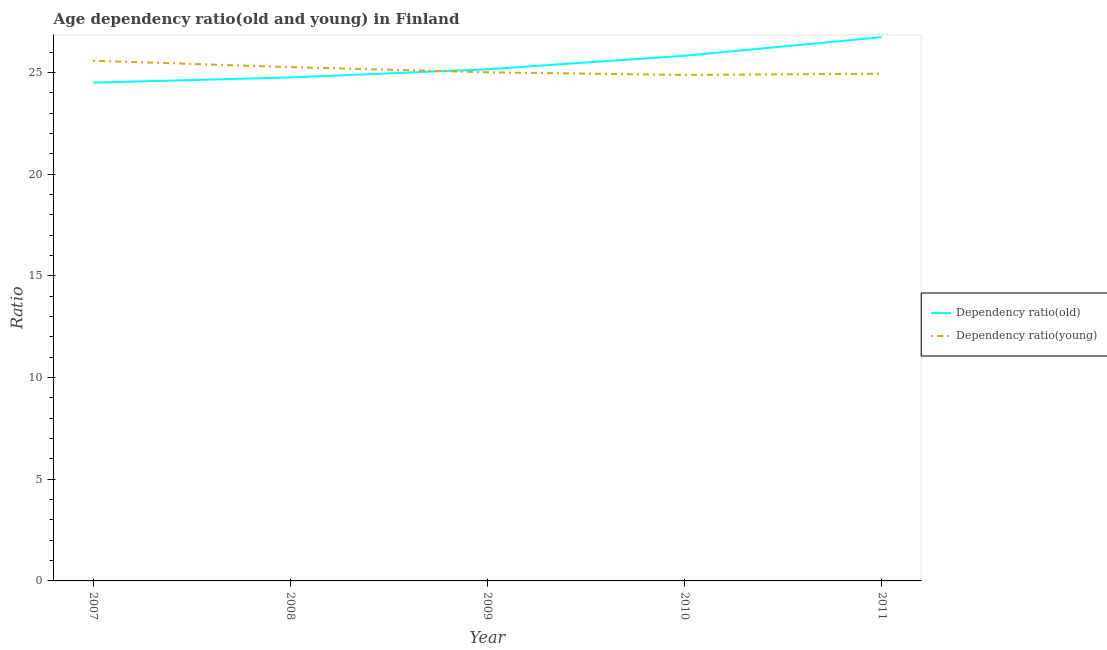What is the age dependency ratio(young) in 2007?
Make the answer very short. 25.57. Across all years, what is the maximum age dependency ratio(old)?
Make the answer very short. 26.73. Across all years, what is the minimum age dependency ratio(young)?
Keep it short and to the point. 24.87. In which year was the age dependency ratio(old) maximum?
Keep it short and to the point. 2011. In which year was the age dependency ratio(young) minimum?
Your answer should be compact. 2010. What is the total age dependency ratio(old) in the graph?
Ensure brevity in your answer.  126.95. What is the difference between the age dependency ratio(young) in 2007 and that in 2008?
Offer a terse response. 0.32. What is the difference between the age dependency ratio(young) in 2010 and the age dependency ratio(old) in 2011?
Make the answer very short. -1.86. What is the average age dependency ratio(young) per year?
Keep it short and to the point. 25.13. In the year 2011, what is the difference between the age dependency ratio(young) and age dependency ratio(old)?
Offer a very short reply. -1.8. In how many years, is the age dependency ratio(old) greater than 8?
Ensure brevity in your answer.  5. What is the ratio of the age dependency ratio(old) in 2007 to that in 2011?
Keep it short and to the point. 0.92. What is the difference between the highest and the second highest age dependency ratio(old)?
Provide a short and direct response. 0.91. What is the difference between the highest and the lowest age dependency ratio(young)?
Your response must be concise. 0.7. Is the sum of the age dependency ratio(young) in 2007 and 2010 greater than the maximum age dependency ratio(old) across all years?
Provide a short and direct response. Yes. Does the age dependency ratio(old) monotonically increase over the years?
Provide a short and direct response. Yes. Is the age dependency ratio(old) strictly greater than the age dependency ratio(young) over the years?
Offer a very short reply. No. How many lines are there?
Offer a very short reply. 2. How many years are there in the graph?
Ensure brevity in your answer.  5. What is the difference between two consecutive major ticks on the Y-axis?
Your answer should be very brief. 5. Are the values on the major ticks of Y-axis written in scientific E-notation?
Your response must be concise. No. Does the graph contain grids?
Your answer should be very brief. No. What is the title of the graph?
Provide a short and direct response. Age dependency ratio(old and young) in Finland. Does "Travel services" appear as one of the legend labels in the graph?
Provide a succinct answer. No. What is the label or title of the Y-axis?
Offer a very short reply. Ratio. What is the Ratio of Dependency ratio(old) in 2007?
Provide a succinct answer. 24.49. What is the Ratio of Dependency ratio(young) in 2007?
Your answer should be very brief. 25.57. What is the Ratio of Dependency ratio(old) in 2008?
Make the answer very short. 24.75. What is the Ratio of Dependency ratio(young) in 2008?
Keep it short and to the point. 25.26. What is the Ratio in Dependency ratio(old) in 2009?
Give a very brief answer. 25.15. What is the Ratio of Dependency ratio(young) in 2009?
Make the answer very short. 25. What is the Ratio of Dependency ratio(old) in 2010?
Your answer should be very brief. 25.82. What is the Ratio of Dependency ratio(young) in 2010?
Your response must be concise. 24.87. What is the Ratio of Dependency ratio(old) in 2011?
Keep it short and to the point. 26.73. What is the Ratio of Dependency ratio(young) in 2011?
Your response must be concise. 24.93. Across all years, what is the maximum Ratio of Dependency ratio(old)?
Offer a terse response. 26.73. Across all years, what is the maximum Ratio in Dependency ratio(young)?
Offer a terse response. 25.57. Across all years, what is the minimum Ratio of Dependency ratio(old)?
Provide a short and direct response. 24.49. Across all years, what is the minimum Ratio in Dependency ratio(young)?
Give a very brief answer. 24.87. What is the total Ratio of Dependency ratio(old) in the graph?
Give a very brief answer. 126.95. What is the total Ratio in Dependency ratio(young) in the graph?
Offer a terse response. 125.64. What is the difference between the Ratio of Dependency ratio(old) in 2007 and that in 2008?
Give a very brief answer. -0.26. What is the difference between the Ratio in Dependency ratio(young) in 2007 and that in 2008?
Your answer should be very brief. 0.32. What is the difference between the Ratio in Dependency ratio(old) in 2007 and that in 2009?
Offer a very short reply. -0.66. What is the difference between the Ratio in Dependency ratio(young) in 2007 and that in 2009?
Provide a short and direct response. 0.57. What is the difference between the Ratio in Dependency ratio(old) in 2007 and that in 2010?
Make the answer very short. -1.32. What is the difference between the Ratio in Dependency ratio(young) in 2007 and that in 2010?
Keep it short and to the point. 0.7. What is the difference between the Ratio of Dependency ratio(old) in 2007 and that in 2011?
Provide a short and direct response. -2.24. What is the difference between the Ratio in Dependency ratio(young) in 2007 and that in 2011?
Your response must be concise. 0.64. What is the difference between the Ratio of Dependency ratio(old) in 2008 and that in 2009?
Make the answer very short. -0.4. What is the difference between the Ratio of Dependency ratio(young) in 2008 and that in 2009?
Keep it short and to the point. 0.26. What is the difference between the Ratio in Dependency ratio(old) in 2008 and that in 2010?
Ensure brevity in your answer.  -1.07. What is the difference between the Ratio in Dependency ratio(young) in 2008 and that in 2010?
Make the answer very short. 0.38. What is the difference between the Ratio in Dependency ratio(old) in 2008 and that in 2011?
Provide a short and direct response. -1.98. What is the difference between the Ratio of Dependency ratio(young) in 2008 and that in 2011?
Your answer should be very brief. 0.32. What is the difference between the Ratio of Dependency ratio(old) in 2009 and that in 2010?
Keep it short and to the point. -0.66. What is the difference between the Ratio of Dependency ratio(young) in 2009 and that in 2010?
Offer a terse response. 0.13. What is the difference between the Ratio of Dependency ratio(old) in 2009 and that in 2011?
Keep it short and to the point. -1.58. What is the difference between the Ratio in Dependency ratio(young) in 2009 and that in 2011?
Provide a succinct answer. 0.07. What is the difference between the Ratio in Dependency ratio(old) in 2010 and that in 2011?
Offer a terse response. -0.91. What is the difference between the Ratio in Dependency ratio(young) in 2010 and that in 2011?
Make the answer very short. -0.06. What is the difference between the Ratio of Dependency ratio(old) in 2007 and the Ratio of Dependency ratio(young) in 2008?
Offer a very short reply. -0.76. What is the difference between the Ratio in Dependency ratio(old) in 2007 and the Ratio in Dependency ratio(young) in 2009?
Make the answer very short. -0.51. What is the difference between the Ratio of Dependency ratio(old) in 2007 and the Ratio of Dependency ratio(young) in 2010?
Offer a terse response. -0.38. What is the difference between the Ratio of Dependency ratio(old) in 2007 and the Ratio of Dependency ratio(young) in 2011?
Offer a very short reply. -0.44. What is the difference between the Ratio of Dependency ratio(old) in 2008 and the Ratio of Dependency ratio(young) in 2009?
Offer a very short reply. -0.25. What is the difference between the Ratio of Dependency ratio(old) in 2008 and the Ratio of Dependency ratio(young) in 2010?
Provide a short and direct response. -0.12. What is the difference between the Ratio of Dependency ratio(old) in 2008 and the Ratio of Dependency ratio(young) in 2011?
Your answer should be very brief. -0.18. What is the difference between the Ratio in Dependency ratio(old) in 2009 and the Ratio in Dependency ratio(young) in 2010?
Make the answer very short. 0.28. What is the difference between the Ratio in Dependency ratio(old) in 2009 and the Ratio in Dependency ratio(young) in 2011?
Your answer should be compact. 0.22. What is the difference between the Ratio in Dependency ratio(old) in 2010 and the Ratio in Dependency ratio(young) in 2011?
Your answer should be compact. 0.88. What is the average Ratio in Dependency ratio(old) per year?
Provide a short and direct response. 25.39. What is the average Ratio of Dependency ratio(young) per year?
Keep it short and to the point. 25.13. In the year 2007, what is the difference between the Ratio in Dependency ratio(old) and Ratio in Dependency ratio(young)?
Your answer should be very brief. -1.08. In the year 2008, what is the difference between the Ratio in Dependency ratio(old) and Ratio in Dependency ratio(young)?
Give a very brief answer. -0.51. In the year 2009, what is the difference between the Ratio in Dependency ratio(old) and Ratio in Dependency ratio(young)?
Ensure brevity in your answer.  0.15. In the year 2010, what is the difference between the Ratio in Dependency ratio(old) and Ratio in Dependency ratio(young)?
Your response must be concise. 0.94. In the year 2011, what is the difference between the Ratio of Dependency ratio(old) and Ratio of Dependency ratio(young)?
Make the answer very short. 1.8. What is the ratio of the Ratio in Dependency ratio(young) in 2007 to that in 2008?
Ensure brevity in your answer.  1.01. What is the ratio of the Ratio of Dependency ratio(old) in 2007 to that in 2009?
Provide a short and direct response. 0.97. What is the ratio of the Ratio of Dependency ratio(young) in 2007 to that in 2009?
Offer a terse response. 1.02. What is the ratio of the Ratio in Dependency ratio(old) in 2007 to that in 2010?
Keep it short and to the point. 0.95. What is the ratio of the Ratio of Dependency ratio(young) in 2007 to that in 2010?
Your answer should be very brief. 1.03. What is the ratio of the Ratio in Dependency ratio(old) in 2007 to that in 2011?
Provide a succinct answer. 0.92. What is the ratio of the Ratio in Dependency ratio(young) in 2007 to that in 2011?
Your response must be concise. 1.03. What is the ratio of the Ratio in Dependency ratio(old) in 2008 to that in 2009?
Offer a very short reply. 0.98. What is the ratio of the Ratio in Dependency ratio(young) in 2008 to that in 2009?
Your response must be concise. 1.01. What is the ratio of the Ratio of Dependency ratio(old) in 2008 to that in 2010?
Your answer should be compact. 0.96. What is the ratio of the Ratio in Dependency ratio(young) in 2008 to that in 2010?
Offer a terse response. 1.02. What is the ratio of the Ratio in Dependency ratio(old) in 2008 to that in 2011?
Provide a succinct answer. 0.93. What is the ratio of the Ratio of Dependency ratio(old) in 2009 to that in 2010?
Offer a very short reply. 0.97. What is the ratio of the Ratio of Dependency ratio(old) in 2009 to that in 2011?
Your response must be concise. 0.94. What is the ratio of the Ratio of Dependency ratio(young) in 2009 to that in 2011?
Keep it short and to the point. 1. What is the ratio of the Ratio of Dependency ratio(old) in 2010 to that in 2011?
Make the answer very short. 0.97. What is the difference between the highest and the second highest Ratio of Dependency ratio(old)?
Offer a terse response. 0.91. What is the difference between the highest and the second highest Ratio in Dependency ratio(young)?
Give a very brief answer. 0.32. What is the difference between the highest and the lowest Ratio of Dependency ratio(old)?
Keep it short and to the point. 2.24. What is the difference between the highest and the lowest Ratio in Dependency ratio(young)?
Offer a very short reply. 0.7. 